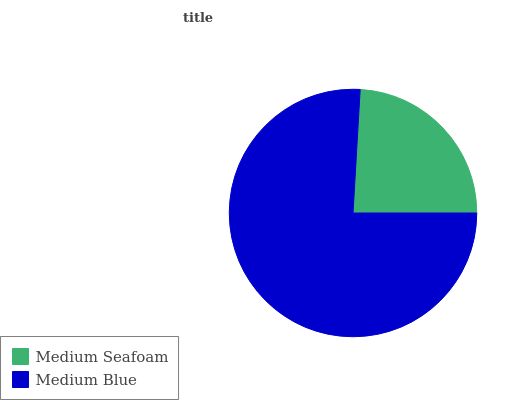Is Medium Seafoam the minimum?
Answer yes or no. Yes. Is Medium Blue the maximum?
Answer yes or no. Yes. Is Medium Blue the minimum?
Answer yes or no. No. Is Medium Blue greater than Medium Seafoam?
Answer yes or no. Yes. Is Medium Seafoam less than Medium Blue?
Answer yes or no. Yes. Is Medium Seafoam greater than Medium Blue?
Answer yes or no. No. Is Medium Blue less than Medium Seafoam?
Answer yes or no. No. Is Medium Blue the high median?
Answer yes or no. Yes. Is Medium Seafoam the low median?
Answer yes or no. Yes. Is Medium Seafoam the high median?
Answer yes or no. No. Is Medium Blue the low median?
Answer yes or no. No. 